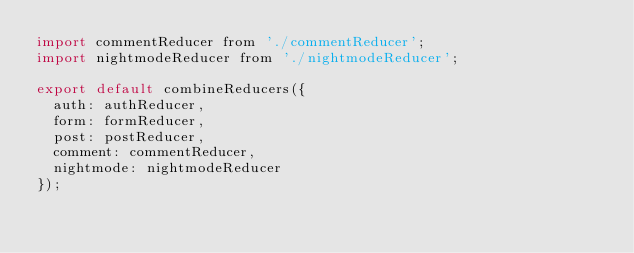<code> <loc_0><loc_0><loc_500><loc_500><_JavaScript_>import commentReducer from './commentReducer';
import nightmodeReducer from './nightmodeReducer';

export default combineReducers({
  auth: authReducer,
  form: formReducer,
	post: postReducer,
  comment: commentReducer,
  nightmode: nightmodeReducer
});</code> 